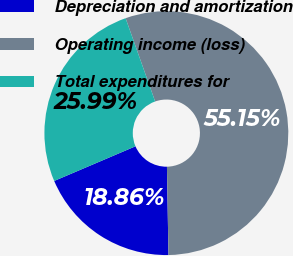Convert chart to OTSL. <chart><loc_0><loc_0><loc_500><loc_500><pie_chart><fcel>Depreciation and amortization<fcel>Operating income (loss)<fcel>Total expenditures for<nl><fcel>18.86%<fcel>55.15%<fcel>25.99%<nl></chart> 